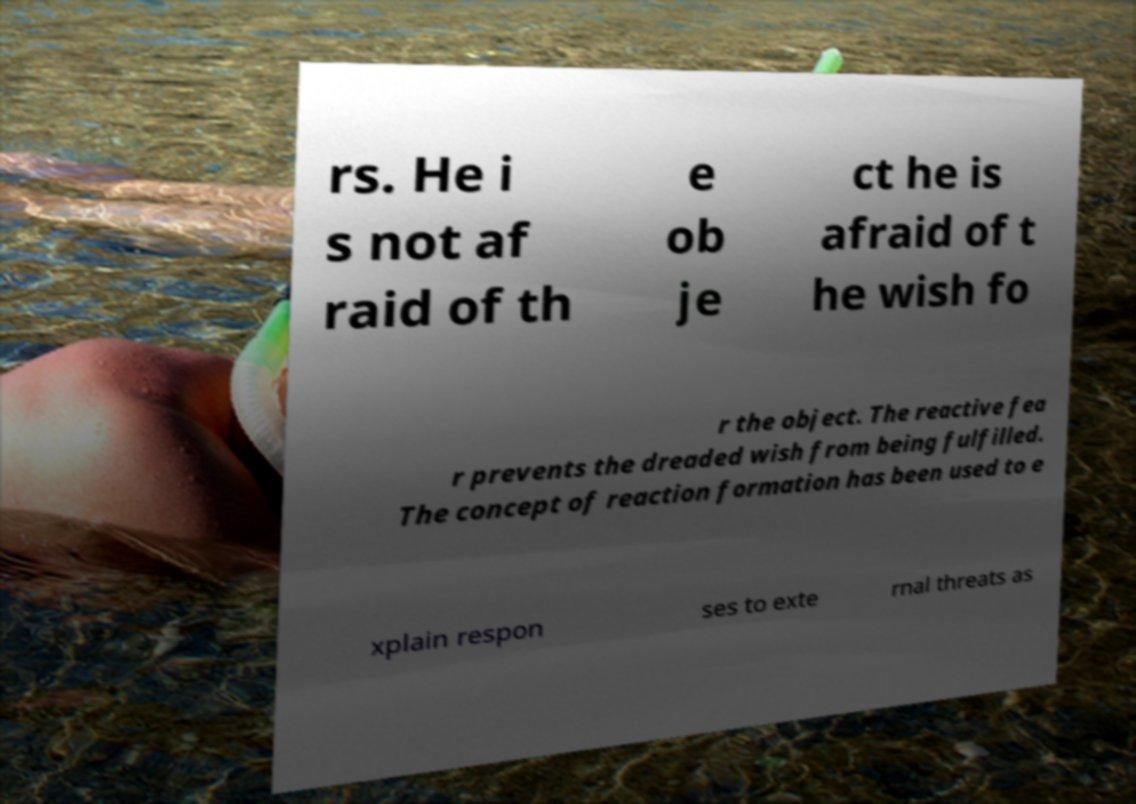There's text embedded in this image that I need extracted. Can you transcribe it verbatim? rs. He i s not af raid of th e ob je ct he is afraid of t he wish fo r the object. The reactive fea r prevents the dreaded wish from being fulfilled. The concept of reaction formation has been used to e xplain respon ses to exte rnal threats as 